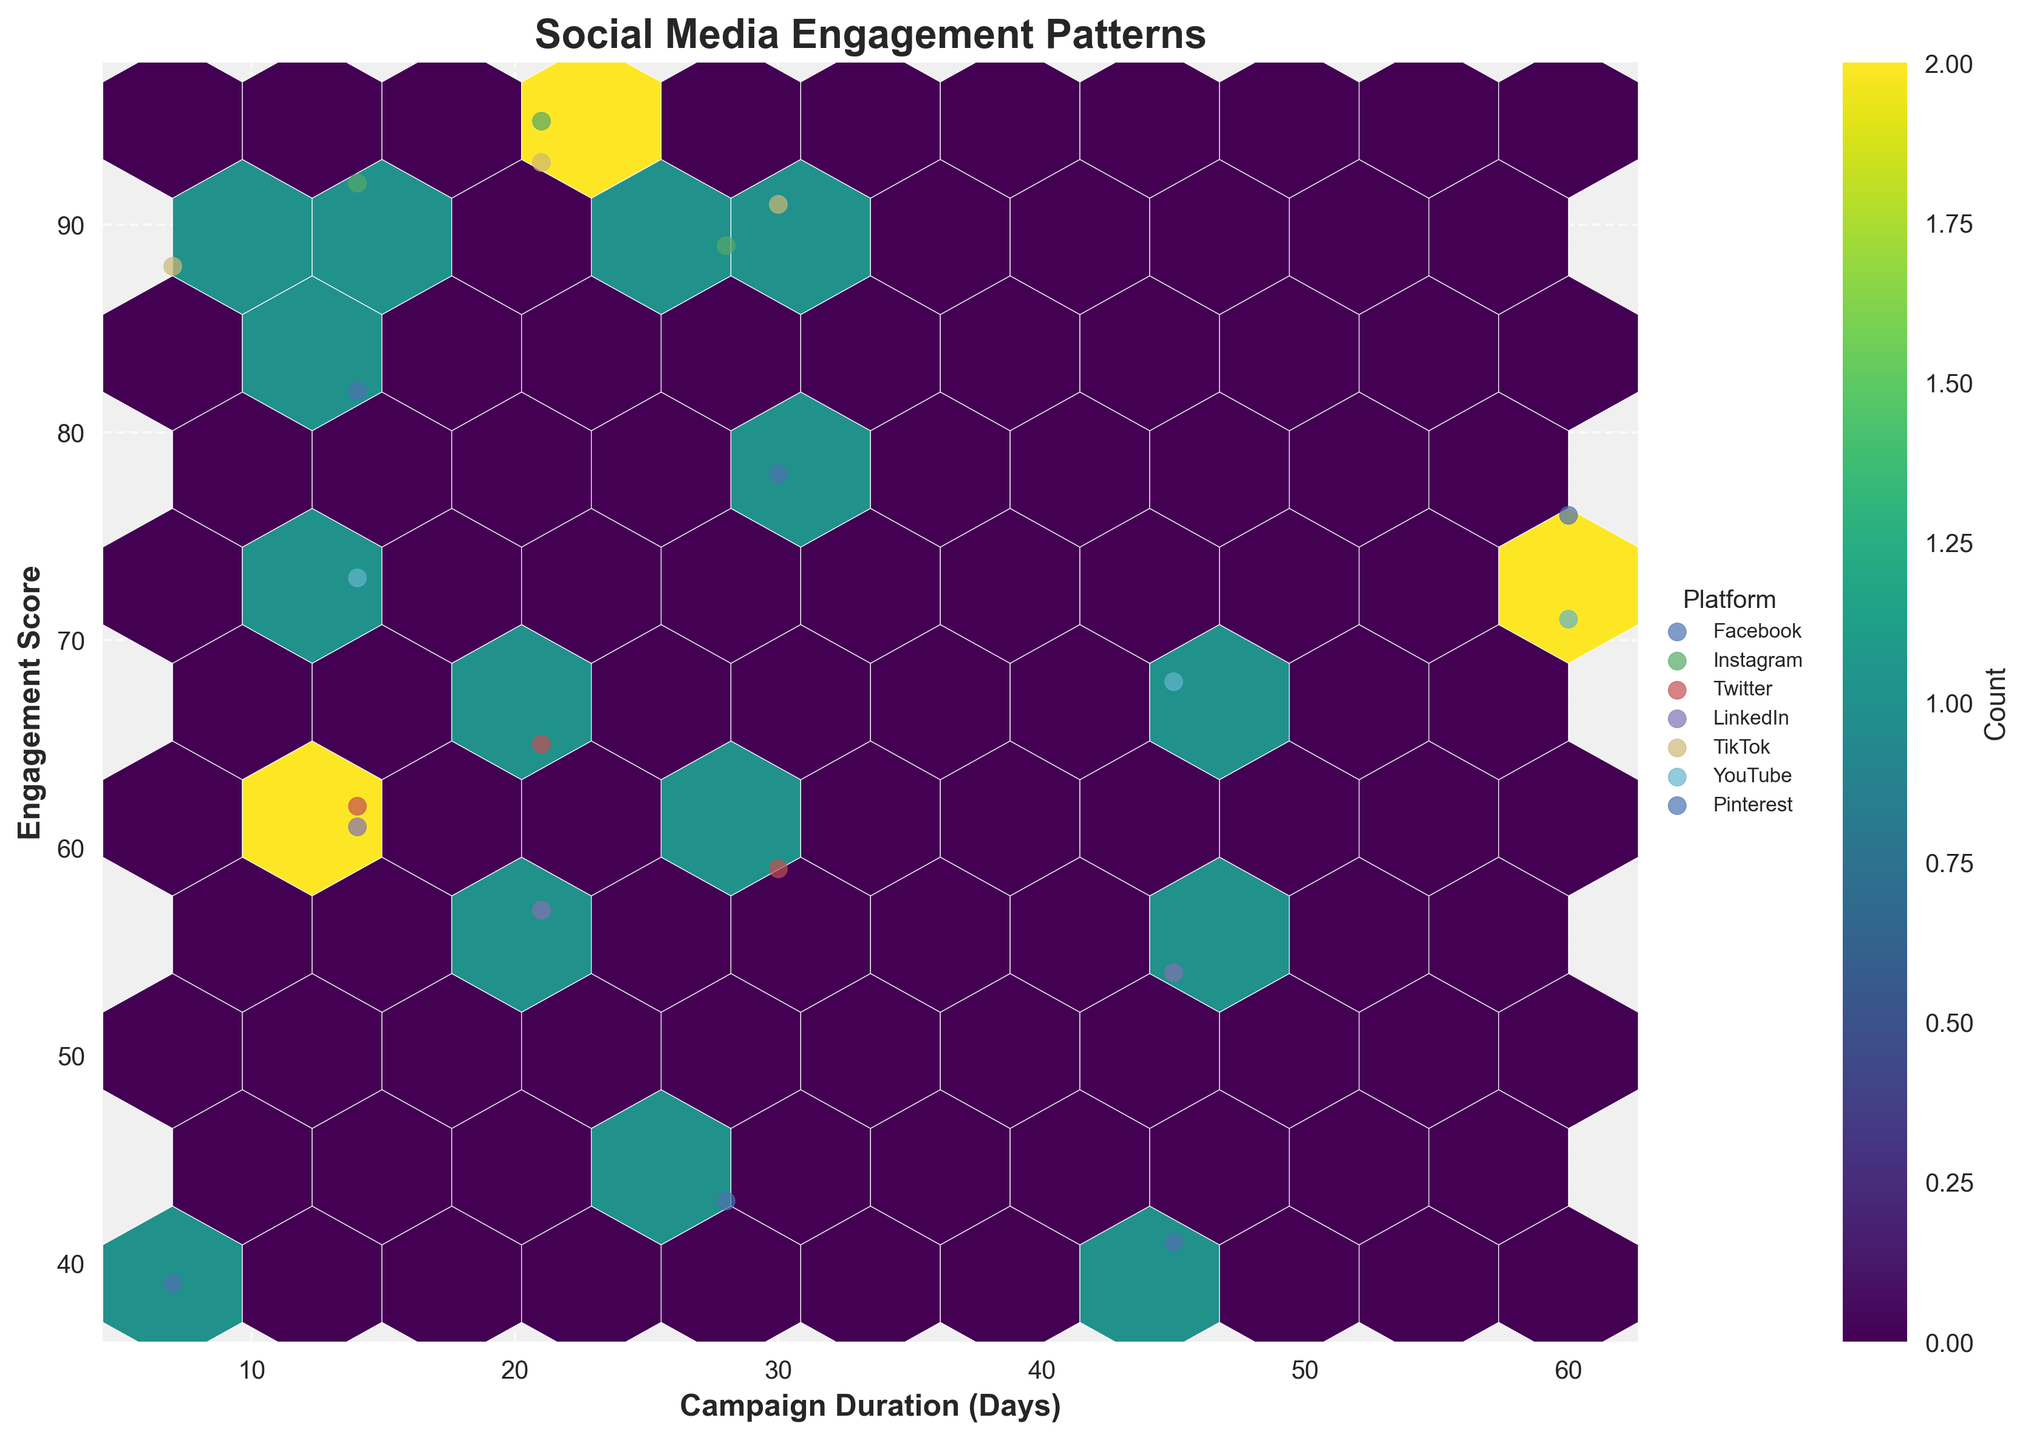What is the title of the figure? The title of the figure is prominently displayed at the top.
Answer: Social Media Engagement Patterns How many color levels are used in the hexagon bins? By observing the color gradient in the hexbin plot and the colorbar legend, we can count the number of distinct levels.
Answer: 10 Which platform has the highest engagement score? We can find the highest point on the y-axis and observe which platform it belongs to.
Answer: Instagram Which campaign duration has the highest concentration of data points? By examining where the hexagon bins are densest, we can identify the common campaign durations.
Answer: Around 14 days and 21 days How does engagement vary with campaign duration? By observing the overall trend in the hexbin plot, we can assess if there is a correlation between engagement scores and campaign duration.
Answer: Longer durations generally show moderate to lower engagement, with some exceptions What is the average engagement score for all platforms running campaigns for 30 days? Identify all data points where the campaign duration is 30 days and calculate the average of their engagement scores. These points are visible on the graph.
Answer: 69.3 Which platform has the widest range of engagement scores? Observe the scatter points for each platform and note the range along the y-axis (engagement score). Compare the ranges for each platform.
Answer: Instagram Compare the engagement scores of TikTok and LinkedIn. Which one generally performs better? By observing the scatter points for both TikTok and LinkedIn, we compare their general positions on the y-axis.
Answer: TikTok How many platforms have all their data points above an engagement score of 50? Count the number of platforms where the lowest engagement score is above 50. This can be determined by observing the scatter distributions per platform.
Answer: Four platforms What is the general trend of the engagement score as the campaign duration increases from 7 to 60 days? Observe the density and trend line of the data points from 7 to 60 days along the x-axis and compare the corresponding engagement scores on the y-axis.
Answer: The trend generally shows a slight decrease or stability in engagement as duration increases 